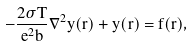Convert formula to latex. <formula><loc_0><loc_0><loc_500><loc_500>- \frac { 2 \sigma T } { e ^ { 2 } b } \nabla ^ { 2 } y ( r ) + y ( r ) = f ( r ) ,</formula> 